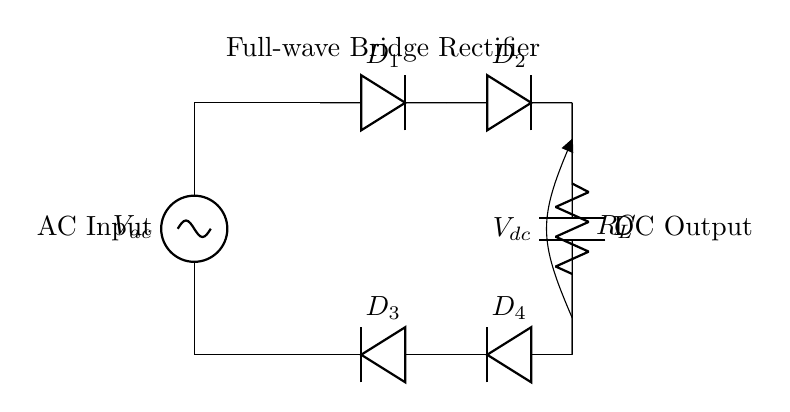What type of rectifier is shown in the circuit? The circuit diagram depicts a full-wave bridge rectifier, characterized by its arrangement of four diodes in a bridge configuration.
Answer: full-wave bridge rectifier How many diodes are in the circuit? The diagram clearly illustrates four diodes, labeled as D1, D2, D3, and D4, interconnected to facilitate the rectification process.
Answer: four diodes What is the purpose of the load resistor, R_L? The load resistor R_L serves the role of converting the electrical energy from the rectified output into usable power, which can drive other components or devices in the circuit.
Answer: to convert electrical energy What is the function of the capacitor, C? The capacitor C is used for smoothing the DC output, reducing voltage fluctuation and ripple that can result from the conversion from AC to DC.
Answer: smoothing the DC output What happens to the direction of current in this circuit? The arrangement of the diodes in the bridge rectifier ensures that the current flows in the same direction through the load, regardless of the AC input polarity, enabling full-wave rectification.
Answer: current flows in the same direction Why is a full-wave rectifier preferred over a half-wave rectifier? A full-wave rectifier is preferred because it utilizes both halves of the AC waveform, resulting in higher efficiency and a smoother DC output compared to a half-wave rectifier, which only uses one half of the waveform.
Answer: higher efficiency and smoother output 